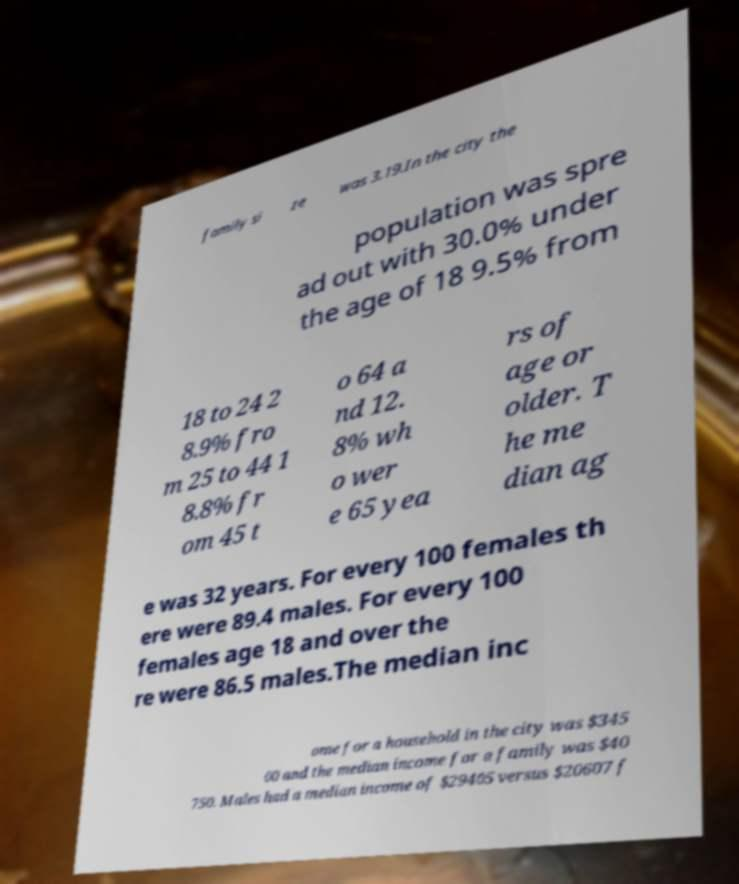Please identify and transcribe the text found in this image. family si ze was 3.19.In the city the population was spre ad out with 30.0% under the age of 18 9.5% from 18 to 24 2 8.9% fro m 25 to 44 1 8.8% fr om 45 t o 64 a nd 12. 8% wh o wer e 65 yea rs of age or older. T he me dian ag e was 32 years. For every 100 females th ere were 89.4 males. For every 100 females age 18 and over the re were 86.5 males.The median inc ome for a household in the city was $345 00 and the median income for a family was $40 750. Males had a median income of $29405 versus $20607 f 